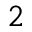<formula> <loc_0><loc_0><loc_500><loc_500>^ { 2 }</formula> 